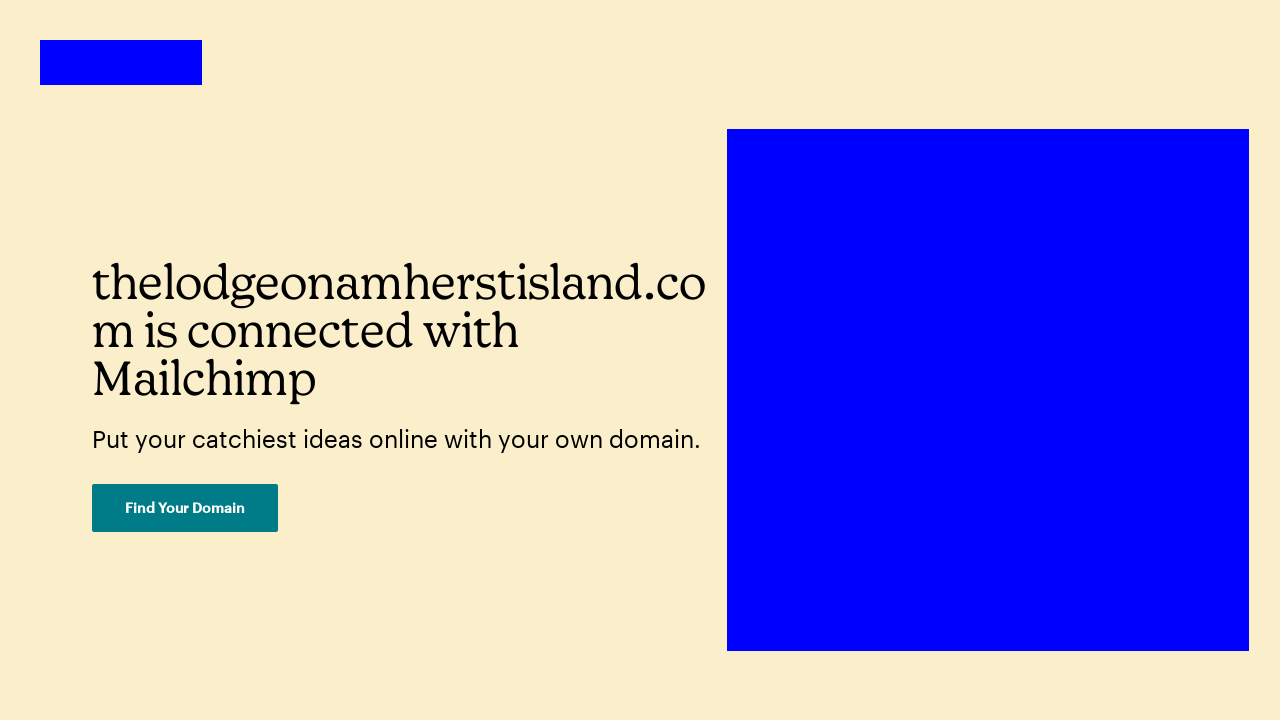Could you detail the process for assembling this website using HTML? To assemble a webpage like the one shown using HTML, you'd start by creating a standard HTML document structure including doctype, html, head, and body tags. Inside the head, include meta tags for charset, viewport and description, and link to any CSS files or inline styles needed for design. The body would contain all visual elements, such as sections, divs, and navigation bars structured with corresponding HTML elements. Text elements like headings and paragraphs are placed inside these containers and styled accordingly. For interactive elements like the 'Find Your Domain' button, you'd use an anchor tag or button tag, with an appropriate href attribute if it links to another page. Lastly, ensure to include alt tags for accessibility and optimize the layout to be responsive using CSS media queries. 